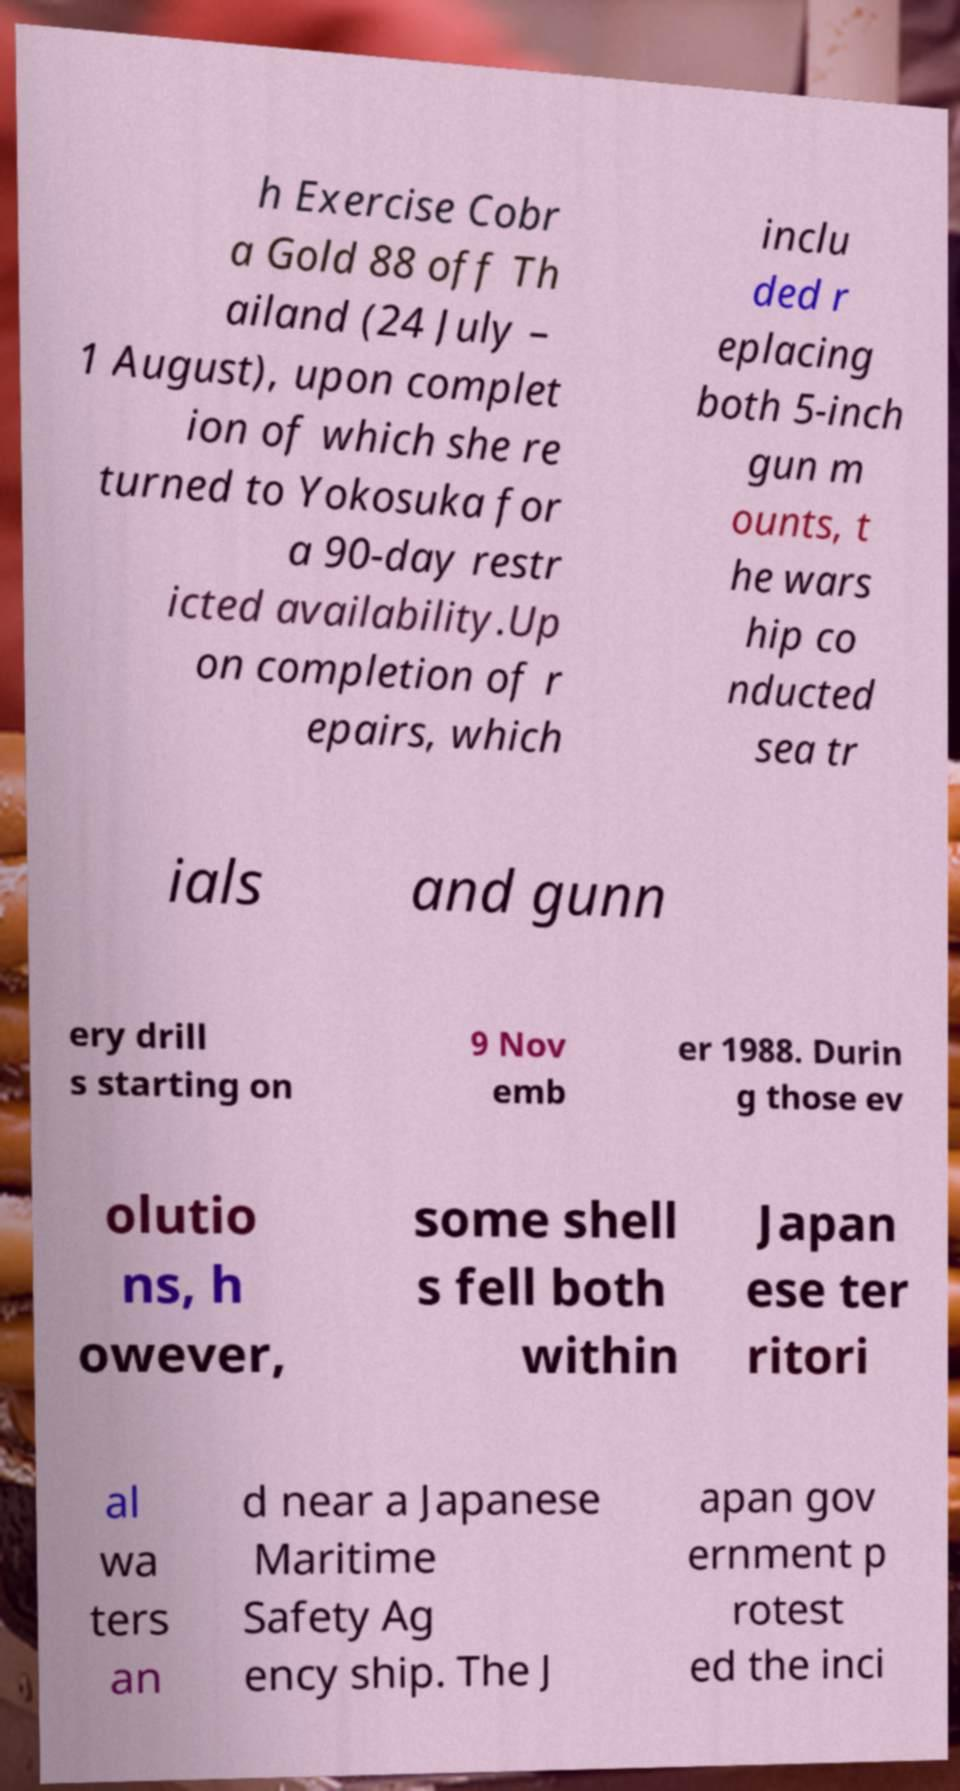Could you extract and type out the text from this image? h Exercise Cobr a Gold 88 off Th ailand (24 July – 1 August), upon complet ion of which she re turned to Yokosuka for a 90-day restr icted availability.Up on completion of r epairs, which inclu ded r eplacing both 5-inch gun m ounts, t he wars hip co nducted sea tr ials and gunn ery drill s starting on 9 Nov emb er 1988. Durin g those ev olutio ns, h owever, some shell s fell both within Japan ese ter ritori al wa ters an d near a Japanese Maritime Safety Ag ency ship. The J apan gov ernment p rotest ed the inci 